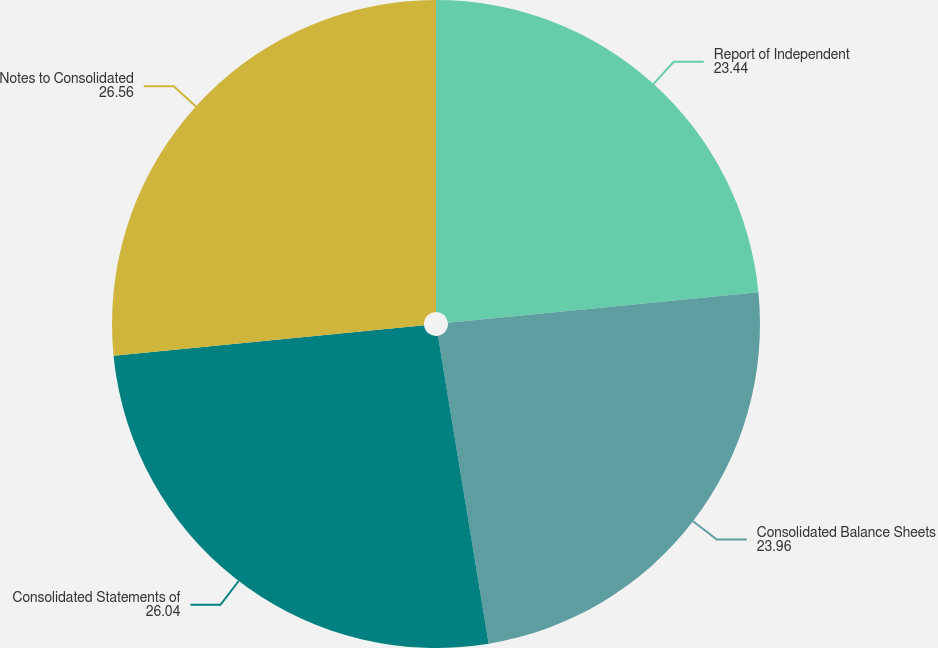Convert chart to OTSL. <chart><loc_0><loc_0><loc_500><loc_500><pie_chart><fcel>Report of Independent<fcel>Consolidated Balance Sheets<fcel>Consolidated Statements of<fcel>Notes to Consolidated<nl><fcel>23.44%<fcel>23.96%<fcel>26.04%<fcel>26.56%<nl></chart> 